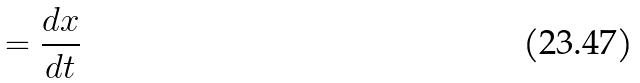Convert formula to latex. <formula><loc_0><loc_0><loc_500><loc_500>= \frac { d x } { d t }</formula> 